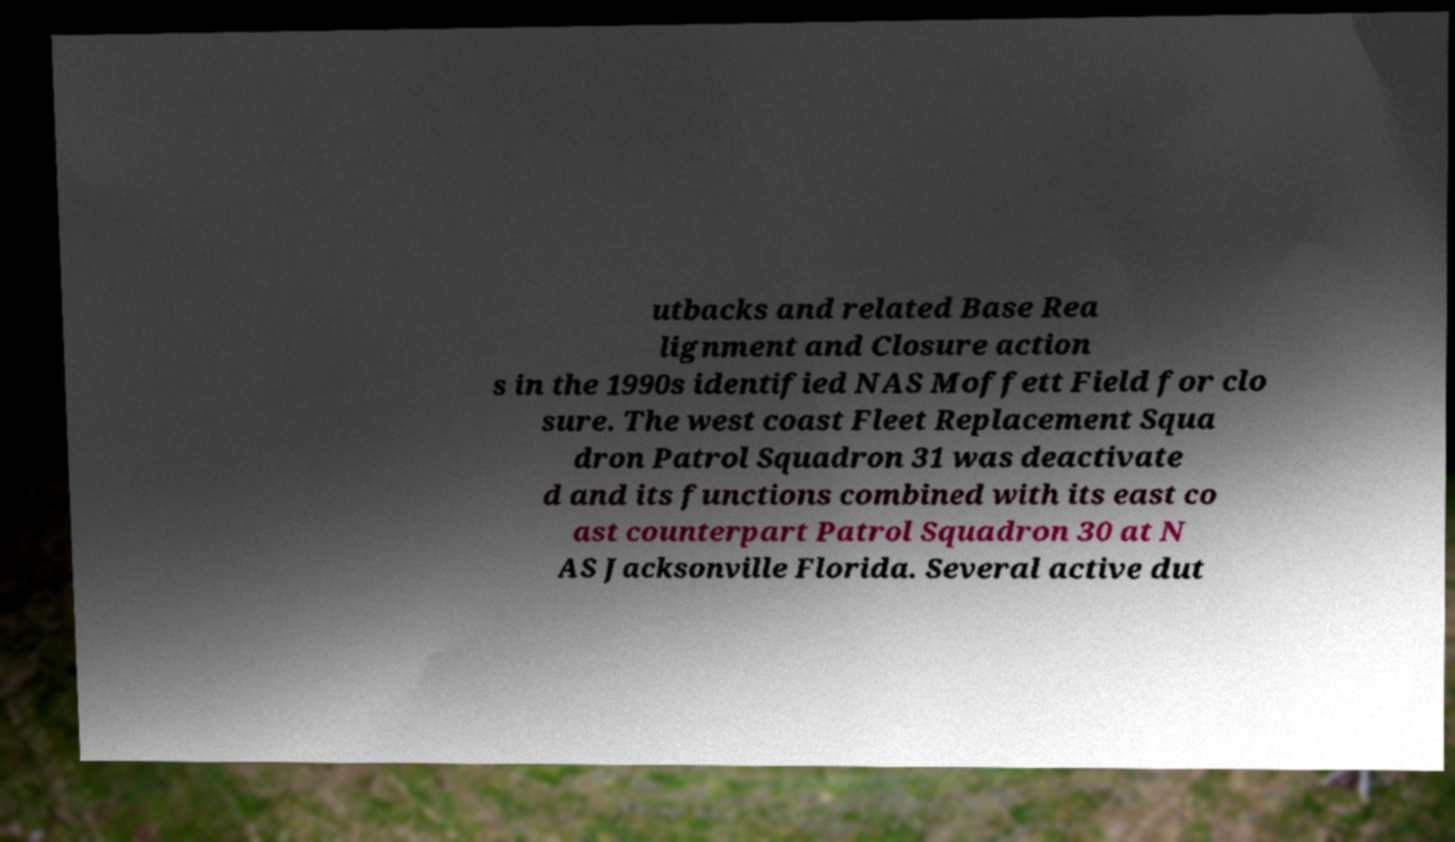Please identify and transcribe the text found in this image. utbacks and related Base Rea lignment and Closure action s in the 1990s identified NAS Moffett Field for clo sure. The west coast Fleet Replacement Squa dron Patrol Squadron 31 was deactivate d and its functions combined with its east co ast counterpart Patrol Squadron 30 at N AS Jacksonville Florida. Several active dut 